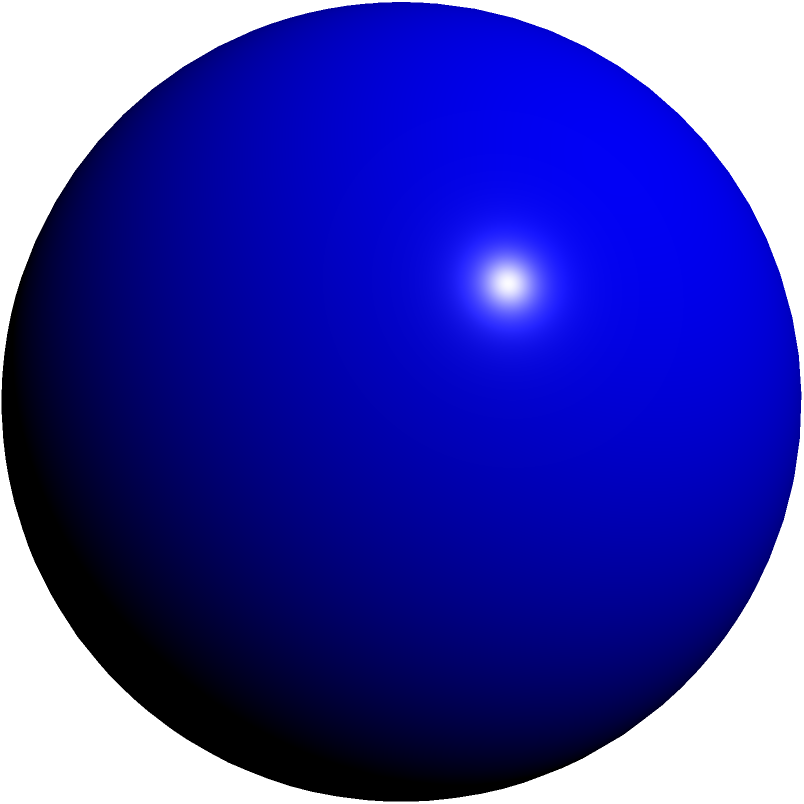In a small village school with limited resources, a teacher wants to demonstrate the concept of surface area using a spherical clay model. If the radius of the sphere is 4 cm, what is its surface area? (Use $\pi = 3.14$) Let's approach this step-by-step:

1) The formula for the surface area of a sphere is:
   $$A = 4\pi r^2$$
   where $A$ is the surface area and $r$ is the radius.

2) We are given that the radius $r = 4$ cm and $\pi = 3.14$.

3) Let's substitute these values into the formula:
   $$A = 4 \times 3.14 \times 4^2$$

4) First, let's calculate $4^2$:
   $$A = 4 \times 3.14 \times 16$$

5) Now, let's multiply:
   $$A = 200.96 \text{ cm}^2$$

6) Rounding to two decimal places:
   $$A \approx 200.96 \text{ cm}^2$$

Therefore, the surface area of the sphere is approximately 200.96 square centimeters.
Answer: $200.96 \text{ cm}^2$ 